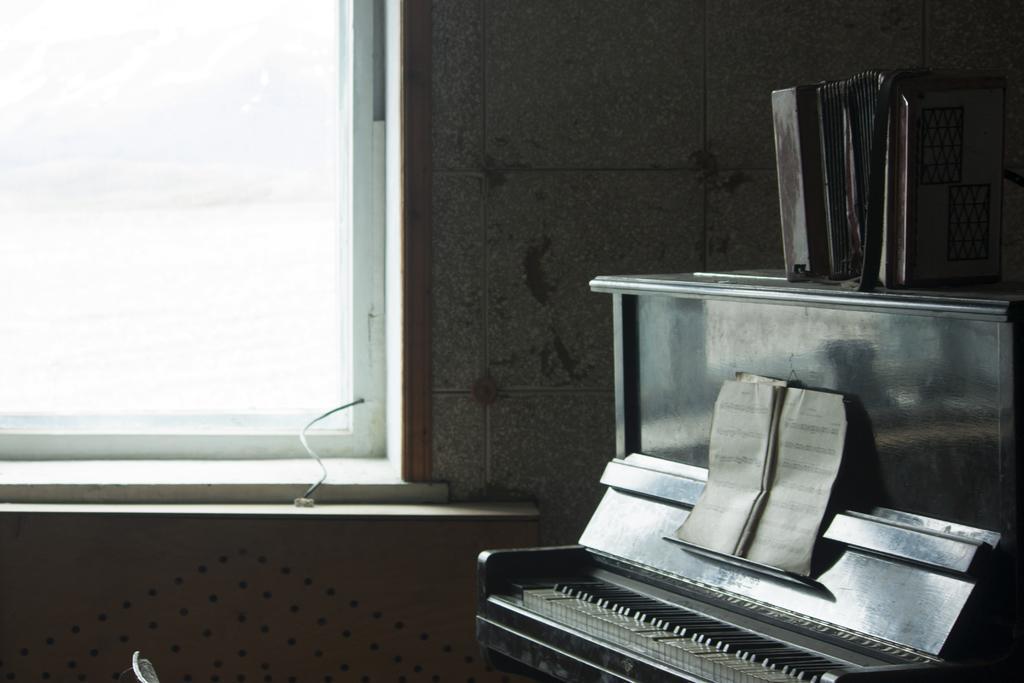Could you give a brief overview of what you see in this image? In this picture there is a piano at the right side of the image and there are some albums which are placed on the piano at the right side of the image and there is a glass window at the left side of the image. 